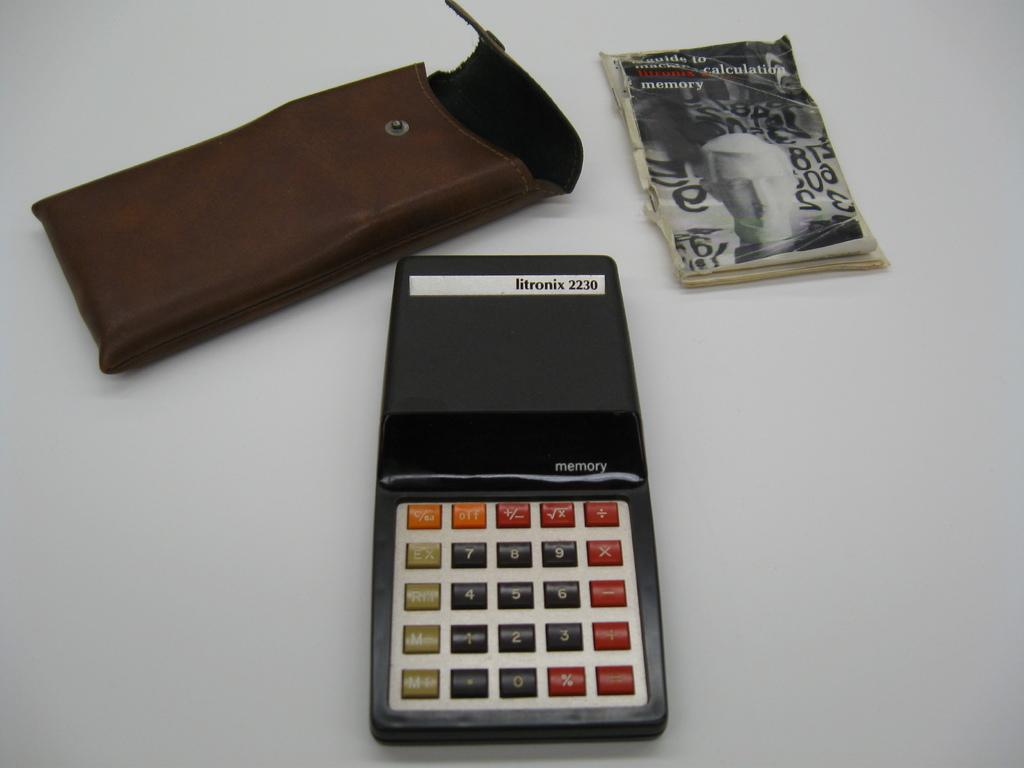Provide a one-sentence caption for the provided image. A Litronix calculator with its holder and guide. 